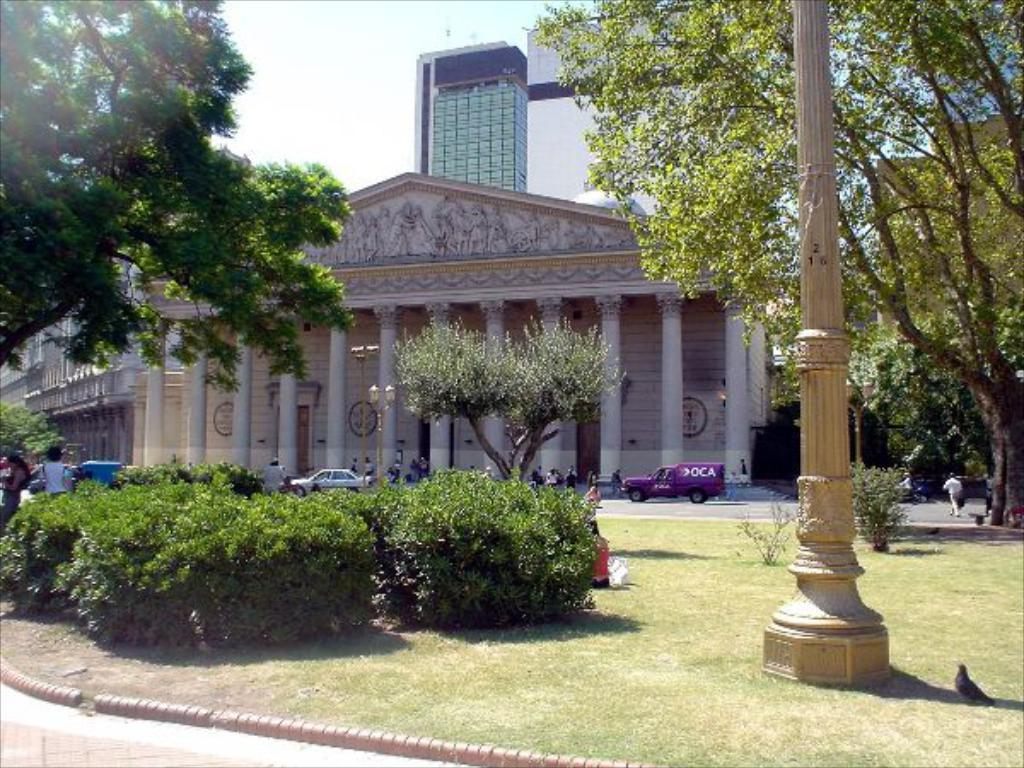What type of structures can be seen in the image? There are buildings in the image. What is happening on the road in the image? There are vehicles on the road in the image. Are there any people present in the image? Yes, there are persons in the image. What type of vegetation is visible in the image? There are plants and grass in the image. What is the ground like in the image? There is a ground visible in the image. What else can be seen in the image? There is a pole in the image. What type of quill is being used by the person in the image? There is no quill present in the image. What event is being shown in the image? The image does not depict a specific event; it shows a scene with buildings, vehicles, persons, plants, a pole, grass, and a ground. 